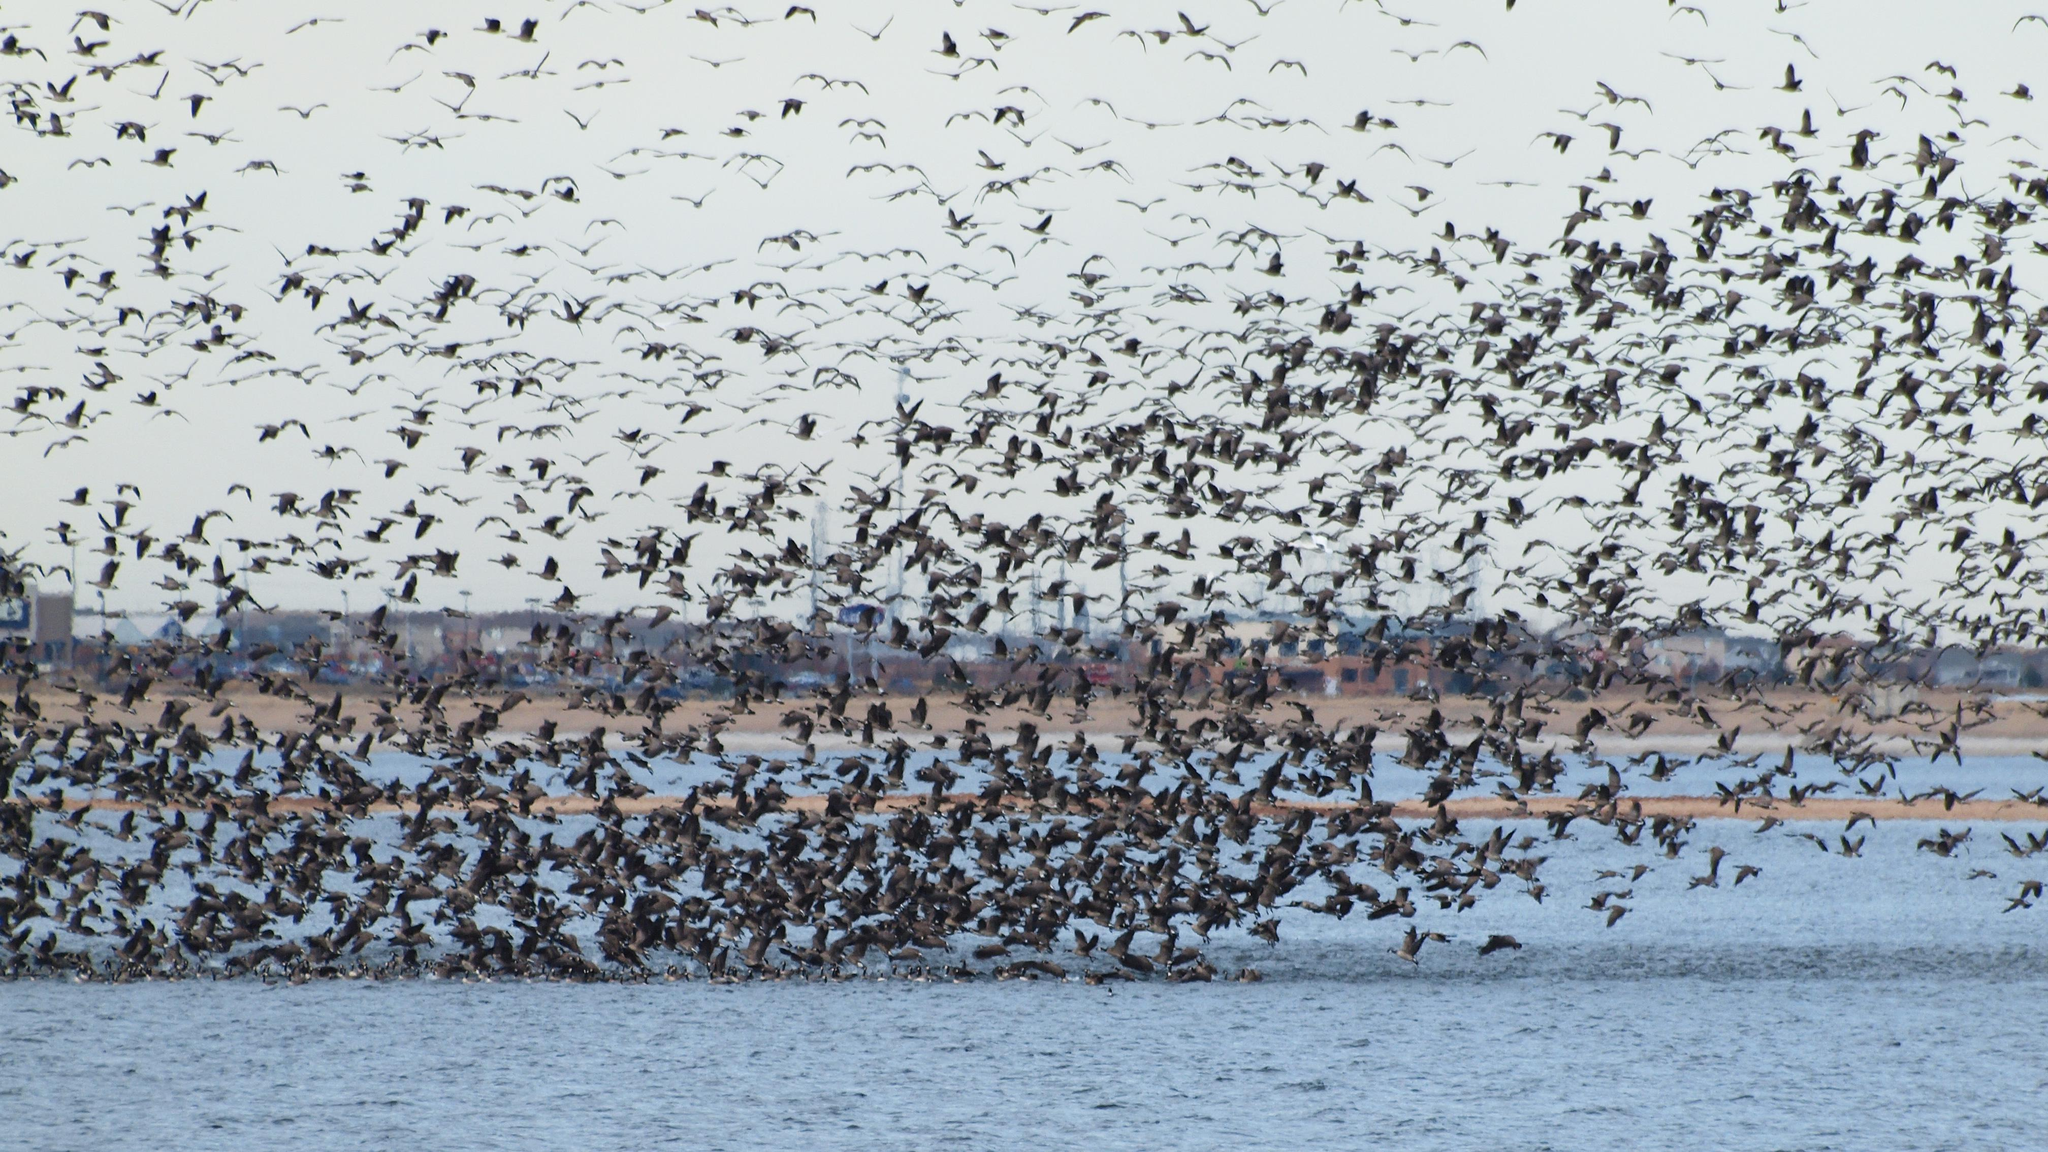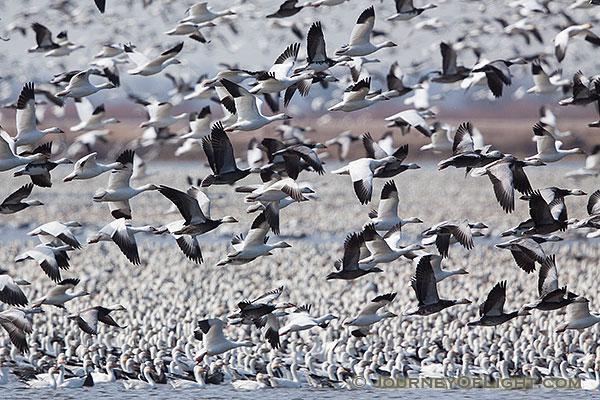The first image is the image on the left, the second image is the image on the right. For the images displayed, is the sentence "Flocks of birds fly over water in at least one image." factually correct? Answer yes or no. Yes. 